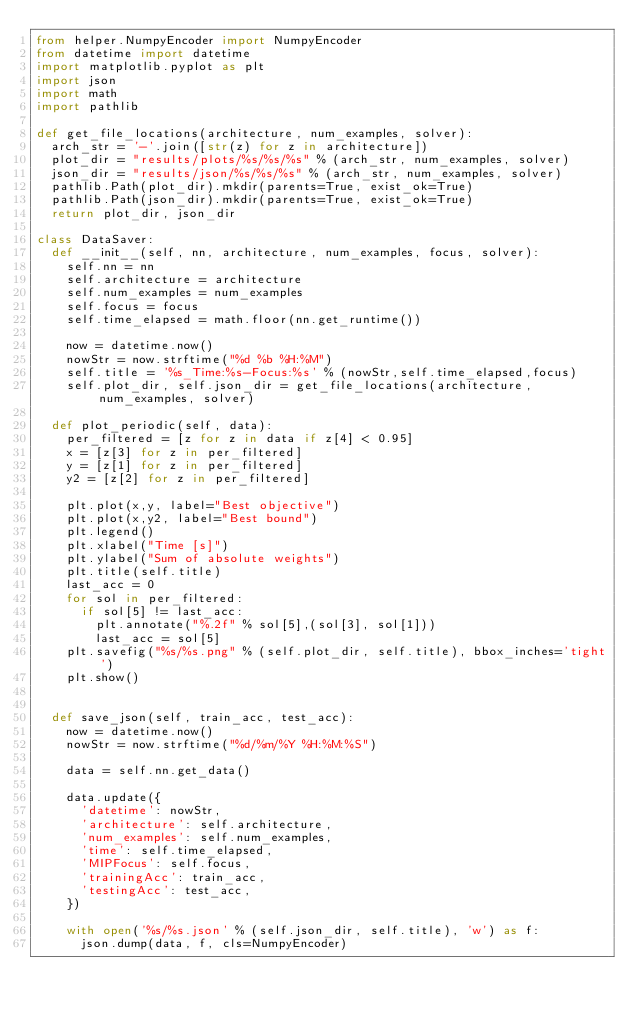<code> <loc_0><loc_0><loc_500><loc_500><_Python_>from helper.NumpyEncoder import NumpyEncoder
from datetime import datetime
import matplotlib.pyplot as plt
import json
import math
import pathlib

def get_file_locations(architecture, num_examples, solver):
  arch_str = '-'.join([str(z) for z in architecture])
  plot_dir = "results/plots/%s/%s/%s" % (arch_str, num_examples, solver)
  json_dir = "results/json/%s/%s/%s" % (arch_str, num_examples, solver)
  pathlib.Path(plot_dir).mkdir(parents=True, exist_ok=True)
  pathlib.Path(json_dir).mkdir(parents=True, exist_ok=True)
  return plot_dir, json_dir

class DataSaver:
  def __init__(self, nn, architecture, num_examples, focus, solver):
    self.nn = nn
    self.architecture = architecture
    self.num_examples = num_examples
    self.focus = focus
    self.time_elapsed = math.floor(nn.get_runtime())

    now = datetime.now()
    nowStr = now.strftime("%d %b %H:%M")
    self.title = '%s_Time:%s-Focus:%s' % (nowStr,self.time_elapsed,focus)
    self.plot_dir, self.json_dir = get_file_locations(architecture, num_examples, solver)

  def plot_periodic(self, data):
    per_filtered = [z for z in data if z[4] < 0.95]
    x = [z[3] for z in per_filtered]
    y = [z[1] for z in per_filtered]
    y2 = [z[2] for z in per_filtered]

    plt.plot(x,y, label="Best objective")
    plt.plot(x,y2, label="Best bound")
    plt.legend()
    plt.xlabel("Time [s]")
    plt.ylabel("Sum of absolute weights")
    plt.title(self.title)
    last_acc = 0
    for sol in per_filtered:
      if sol[5] != last_acc:
        plt.annotate("%.2f" % sol[5],(sol[3], sol[1]))
        last_acc = sol[5]
    plt.savefig("%s/%s.png" % (self.plot_dir, self.title), bbox_inches='tight')
    plt.show()


  def save_json(self, train_acc, test_acc):
    now = datetime.now()
    nowStr = now.strftime("%d/%m/%Y %H:%M:%S")

    data = self.nn.get_data()

    data.update({
      'datetime': nowStr,
      'architecture': self.architecture,
      'num_examples': self.num_examples,
      'time': self.time_elapsed,
      'MIPFocus': self.focus,
      'trainingAcc': train_acc,
      'testingAcc': test_acc,
    })

    with open('%s/%s.json' % (self.json_dir, self.title), 'w') as f:
      json.dump(data, f, cls=NumpyEncoder)</code> 